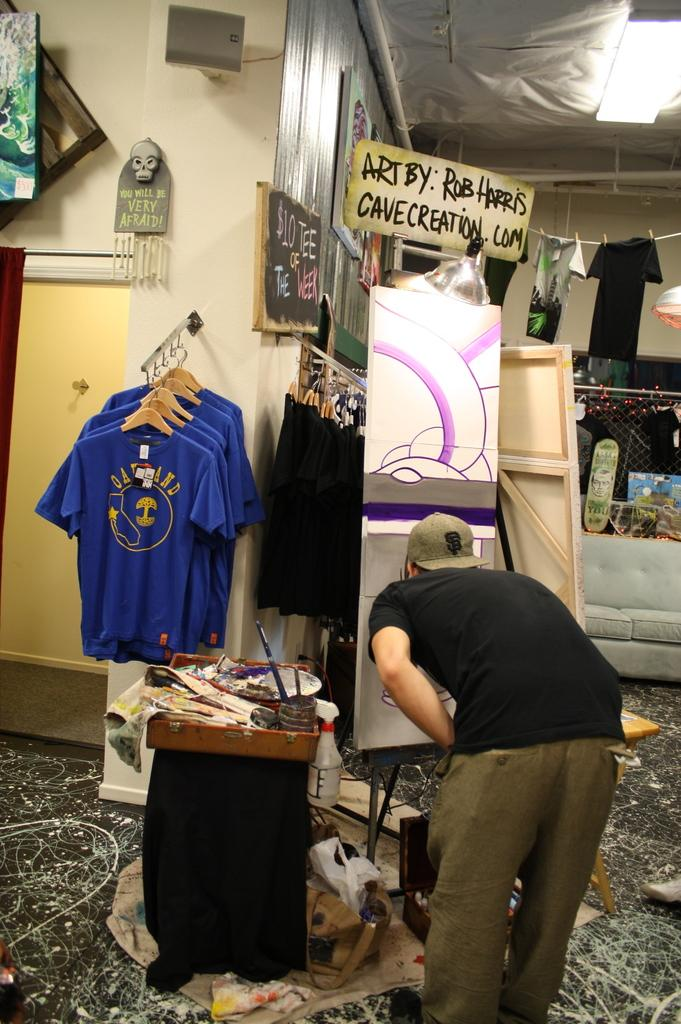<image>
Share a concise interpretation of the image provided. The art in this store is created by artist Rob Harris. 